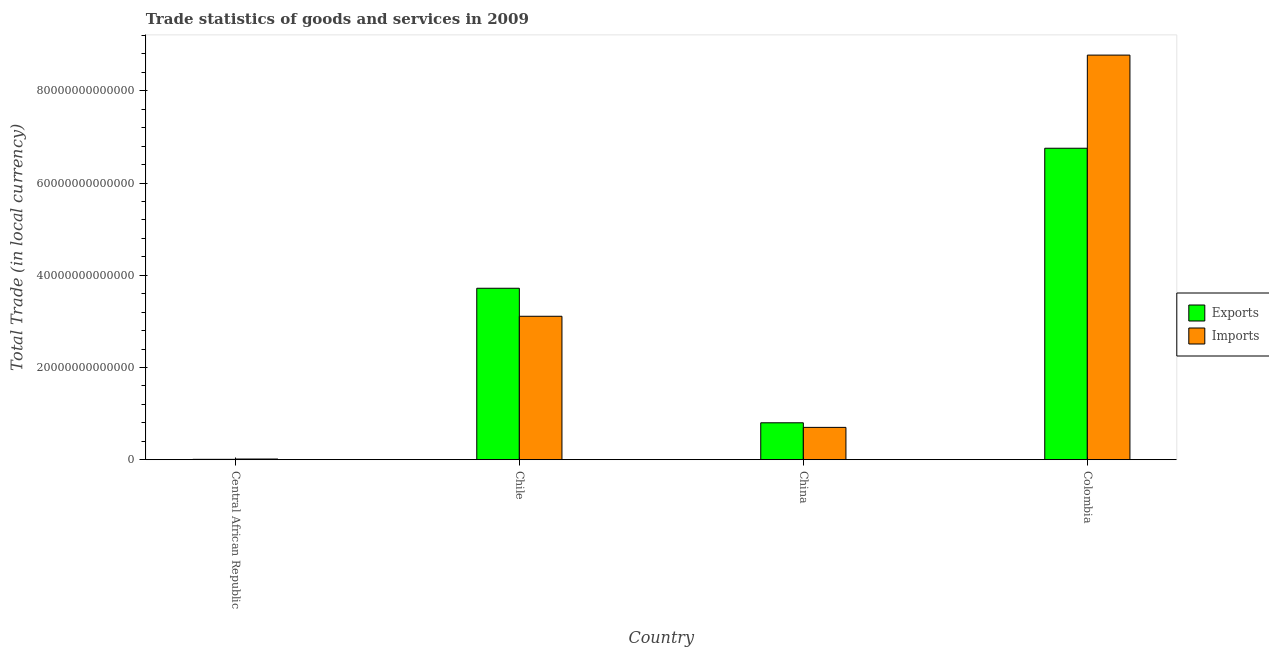How many groups of bars are there?
Your answer should be very brief. 4. Are the number of bars per tick equal to the number of legend labels?
Your answer should be very brief. Yes. Are the number of bars on each tick of the X-axis equal?
Offer a terse response. Yes. What is the label of the 1st group of bars from the left?
Your answer should be very brief. Central African Republic. In how many cases, is the number of bars for a given country not equal to the number of legend labels?
Give a very brief answer. 0. What is the export of goods and services in Chile?
Provide a succinct answer. 3.72e+13. Across all countries, what is the maximum imports of goods and services?
Offer a very short reply. 8.77e+13. Across all countries, what is the minimum imports of goods and services?
Your answer should be compact. 1.46e+11. In which country was the export of goods and services maximum?
Keep it short and to the point. Colombia. In which country was the imports of goods and services minimum?
Ensure brevity in your answer.  Central African Republic. What is the total export of goods and services in the graph?
Your answer should be compact. 1.13e+14. What is the difference between the imports of goods and services in Chile and that in China?
Your answer should be compact. 2.41e+13. What is the difference between the imports of goods and services in Chile and the export of goods and services in Colombia?
Keep it short and to the point. -3.64e+13. What is the average imports of goods and services per country?
Offer a terse response. 3.15e+13. What is the difference between the export of goods and services and imports of goods and services in Colombia?
Make the answer very short. -2.02e+13. In how many countries, is the export of goods and services greater than 8000000000000 LCU?
Make the answer very short. 3. What is the ratio of the imports of goods and services in Chile to that in Colombia?
Your response must be concise. 0.35. Is the export of goods and services in Central African Republic less than that in Colombia?
Give a very brief answer. Yes. Is the difference between the imports of goods and services in Chile and China greater than the difference between the export of goods and services in Chile and China?
Your answer should be compact. No. What is the difference between the highest and the second highest imports of goods and services?
Offer a terse response. 5.66e+13. What is the difference between the highest and the lowest imports of goods and services?
Offer a terse response. 8.76e+13. Is the sum of the export of goods and services in Chile and Colombia greater than the maximum imports of goods and services across all countries?
Your answer should be compact. Yes. What does the 1st bar from the left in Colombia represents?
Provide a short and direct response. Exports. What does the 1st bar from the right in China represents?
Offer a terse response. Imports. Are all the bars in the graph horizontal?
Keep it short and to the point. No. What is the difference between two consecutive major ticks on the Y-axis?
Offer a terse response. 2.00e+13. Does the graph contain any zero values?
Offer a very short reply. No. How many legend labels are there?
Give a very brief answer. 2. What is the title of the graph?
Give a very brief answer. Trade statistics of goods and services in 2009. What is the label or title of the X-axis?
Provide a short and direct response. Country. What is the label or title of the Y-axis?
Offer a very short reply. Total Trade (in local currency). What is the Total Trade (in local currency) of Exports in Central African Republic?
Give a very brief answer. 7.96e+1. What is the Total Trade (in local currency) of Imports in Central African Republic?
Provide a succinct answer. 1.46e+11. What is the Total Trade (in local currency) of Exports in Chile?
Offer a terse response. 3.72e+13. What is the Total Trade (in local currency) of Imports in Chile?
Make the answer very short. 3.11e+13. What is the Total Trade (in local currency) in Exports in China?
Provide a short and direct response. 8.00e+12. What is the Total Trade (in local currency) in Imports in China?
Keep it short and to the point. 7.01e+12. What is the Total Trade (in local currency) in Exports in Colombia?
Your answer should be compact. 6.75e+13. What is the Total Trade (in local currency) in Imports in Colombia?
Your answer should be very brief. 8.77e+13. Across all countries, what is the maximum Total Trade (in local currency) of Exports?
Your response must be concise. 6.75e+13. Across all countries, what is the maximum Total Trade (in local currency) of Imports?
Provide a succinct answer. 8.77e+13. Across all countries, what is the minimum Total Trade (in local currency) in Exports?
Make the answer very short. 7.96e+1. Across all countries, what is the minimum Total Trade (in local currency) of Imports?
Your response must be concise. 1.46e+11. What is the total Total Trade (in local currency) in Exports in the graph?
Provide a succinct answer. 1.13e+14. What is the total Total Trade (in local currency) of Imports in the graph?
Your response must be concise. 1.26e+14. What is the difference between the Total Trade (in local currency) of Exports in Central African Republic and that in Chile?
Your response must be concise. -3.71e+13. What is the difference between the Total Trade (in local currency) of Imports in Central African Republic and that in Chile?
Your answer should be very brief. -3.10e+13. What is the difference between the Total Trade (in local currency) in Exports in Central African Republic and that in China?
Provide a short and direct response. -7.92e+12. What is the difference between the Total Trade (in local currency) of Imports in Central African Republic and that in China?
Your response must be concise. -6.86e+12. What is the difference between the Total Trade (in local currency) of Exports in Central African Republic and that in Colombia?
Keep it short and to the point. -6.75e+13. What is the difference between the Total Trade (in local currency) in Imports in Central African Republic and that in Colombia?
Provide a succinct answer. -8.76e+13. What is the difference between the Total Trade (in local currency) in Exports in Chile and that in China?
Give a very brief answer. 2.92e+13. What is the difference between the Total Trade (in local currency) in Imports in Chile and that in China?
Keep it short and to the point. 2.41e+13. What is the difference between the Total Trade (in local currency) in Exports in Chile and that in Colombia?
Your response must be concise. -3.04e+13. What is the difference between the Total Trade (in local currency) in Imports in Chile and that in Colombia?
Provide a succinct answer. -5.66e+13. What is the difference between the Total Trade (in local currency) in Exports in China and that in Colombia?
Keep it short and to the point. -5.95e+13. What is the difference between the Total Trade (in local currency) in Imports in China and that in Colombia?
Your answer should be compact. -8.07e+13. What is the difference between the Total Trade (in local currency) in Exports in Central African Republic and the Total Trade (in local currency) in Imports in Chile?
Your answer should be compact. -3.10e+13. What is the difference between the Total Trade (in local currency) of Exports in Central African Republic and the Total Trade (in local currency) of Imports in China?
Offer a terse response. -6.93e+12. What is the difference between the Total Trade (in local currency) of Exports in Central African Republic and the Total Trade (in local currency) of Imports in Colombia?
Ensure brevity in your answer.  -8.77e+13. What is the difference between the Total Trade (in local currency) in Exports in Chile and the Total Trade (in local currency) in Imports in China?
Make the answer very short. 3.02e+13. What is the difference between the Total Trade (in local currency) in Exports in Chile and the Total Trade (in local currency) in Imports in Colombia?
Give a very brief answer. -5.06e+13. What is the difference between the Total Trade (in local currency) of Exports in China and the Total Trade (in local currency) of Imports in Colombia?
Offer a terse response. -7.97e+13. What is the average Total Trade (in local currency) of Exports per country?
Provide a short and direct response. 2.82e+13. What is the average Total Trade (in local currency) in Imports per country?
Ensure brevity in your answer.  3.15e+13. What is the difference between the Total Trade (in local currency) of Exports and Total Trade (in local currency) of Imports in Central African Republic?
Keep it short and to the point. -6.66e+1. What is the difference between the Total Trade (in local currency) of Exports and Total Trade (in local currency) of Imports in Chile?
Give a very brief answer. 6.08e+12. What is the difference between the Total Trade (in local currency) in Exports and Total Trade (in local currency) in Imports in China?
Your answer should be very brief. 9.97e+11. What is the difference between the Total Trade (in local currency) in Exports and Total Trade (in local currency) in Imports in Colombia?
Your answer should be compact. -2.02e+13. What is the ratio of the Total Trade (in local currency) of Exports in Central African Republic to that in Chile?
Your answer should be compact. 0. What is the ratio of the Total Trade (in local currency) of Imports in Central African Republic to that in Chile?
Keep it short and to the point. 0. What is the ratio of the Total Trade (in local currency) in Exports in Central African Republic to that in China?
Give a very brief answer. 0.01. What is the ratio of the Total Trade (in local currency) of Imports in Central African Republic to that in China?
Give a very brief answer. 0.02. What is the ratio of the Total Trade (in local currency) in Exports in Central African Republic to that in Colombia?
Ensure brevity in your answer.  0. What is the ratio of the Total Trade (in local currency) of Imports in Central African Republic to that in Colombia?
Keep it short and to the point. 0. What is the ratio of the Total Trade (in local currency) in Exports in Chile to that in China?
Make the answer very short. 4.65. What is the ratio of the Total Trade (in local currency) of Imports in Chile to that in China?
Offer a terse response. 4.44. What is the ratio of the Total Trade (in local currency) in Exports in Chile to that in Colombia?
Your answer should be very brief. 0.55. What is the ratio of the Total Trade (in local currency) of Imports in Chile to that in Colombia?
Your answer should be compact. 0.35. What is the ratio of the Total Trade (in local currency) of Exports in China to that in Colombia?
Ensure brevity in your answer.  0.12. What is the ratio of the Total Trade (in local currency) of Imports in China to that in Colombia?
Give a very brief answer. 0.08. What is the difference between the highest and the second highest Total Trade (in local currency) of Exports?
Make the answer very short. 3.04e+13. What is the difference between the highest and the second highest Total Trade (in local currency) of Imports?
Keep it short and to the point. 5.66e+13. What is the difference between the highest and the lowest Total Trade (in local currency) in Exports?
Ensure brevity in your answer.  6.75e+13. What is the difference between the highest and the lowest Total Trade (in local currency) in Imports?
Offer a very short reply. 8.76e+13. 